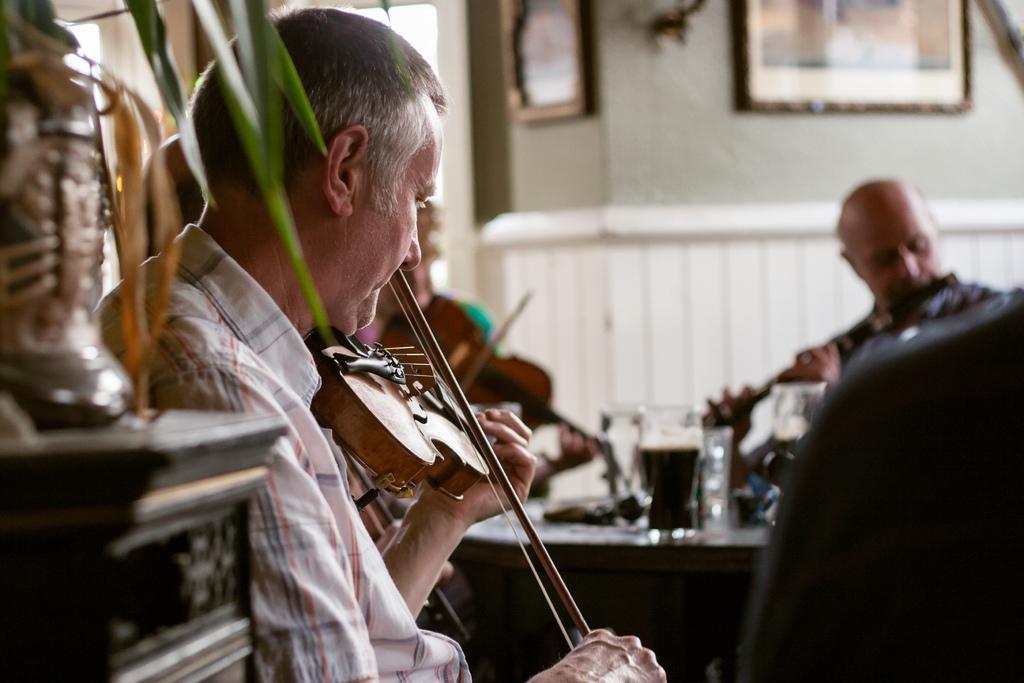In one or two sentences, can you explain what this image depicts? Here we can see a person sitting and playing the violin, and in front here is the table and glasses and some objects on it, and here is the wall and photo frames on it. 